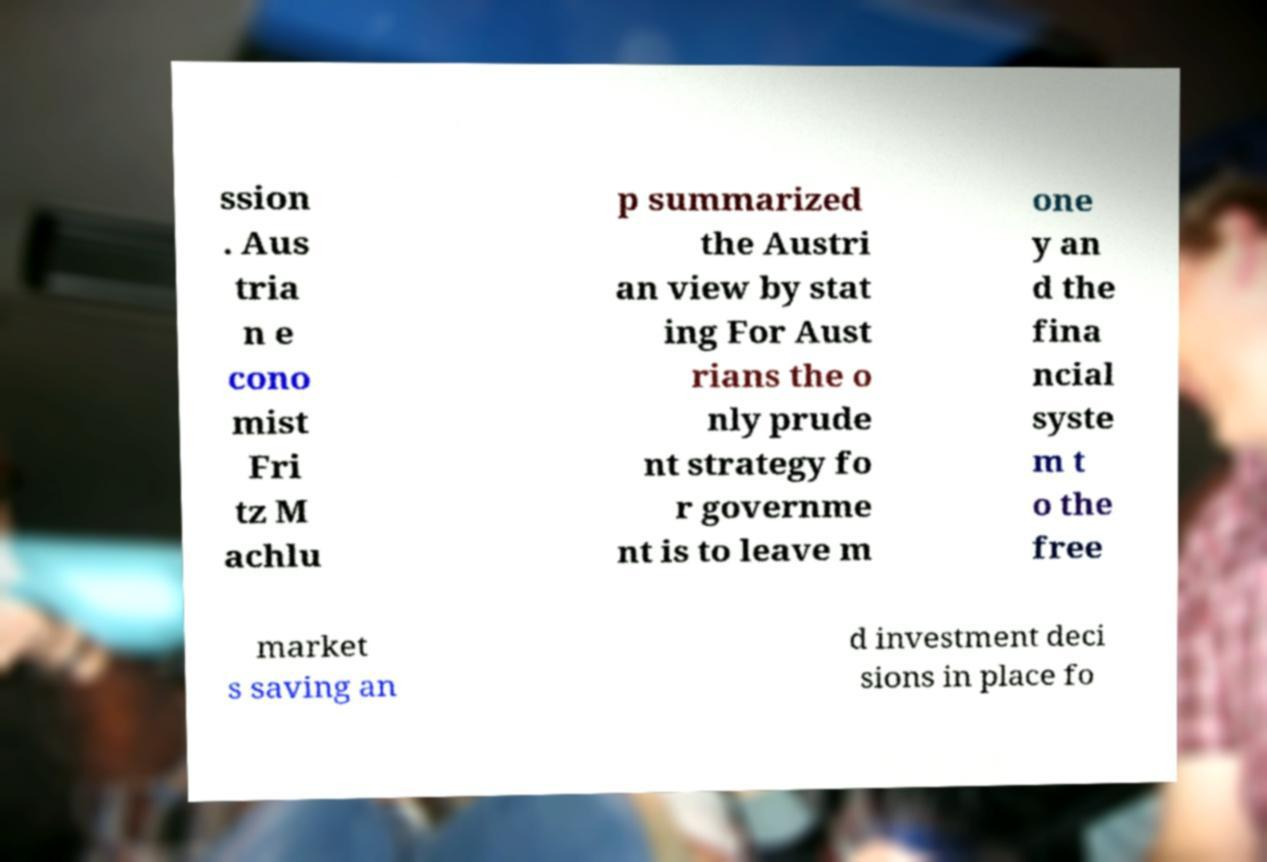There's text embedded in this image that I need extracted. Can you transcribe it verbatim? ssion . Aus tria n e cono mist Fri tz M achlu p summarized the Austri an view by stat ing For Aust rians the o nly prude nt strategy fo r governme nt is to leave m one y an d the fina ncial syste m t o the free market s saving an d investment deci sions in place fo 